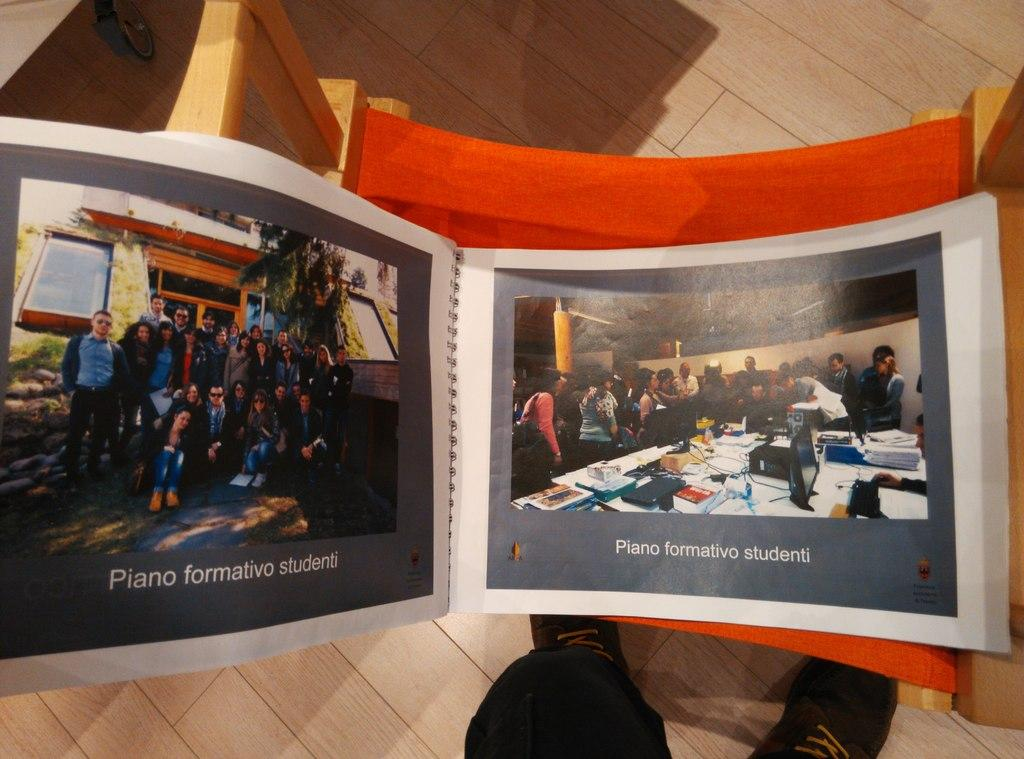<image>
Render a clear and concise summary of the photo. The picture album contained images for the "Piano formativo studenti" club. 